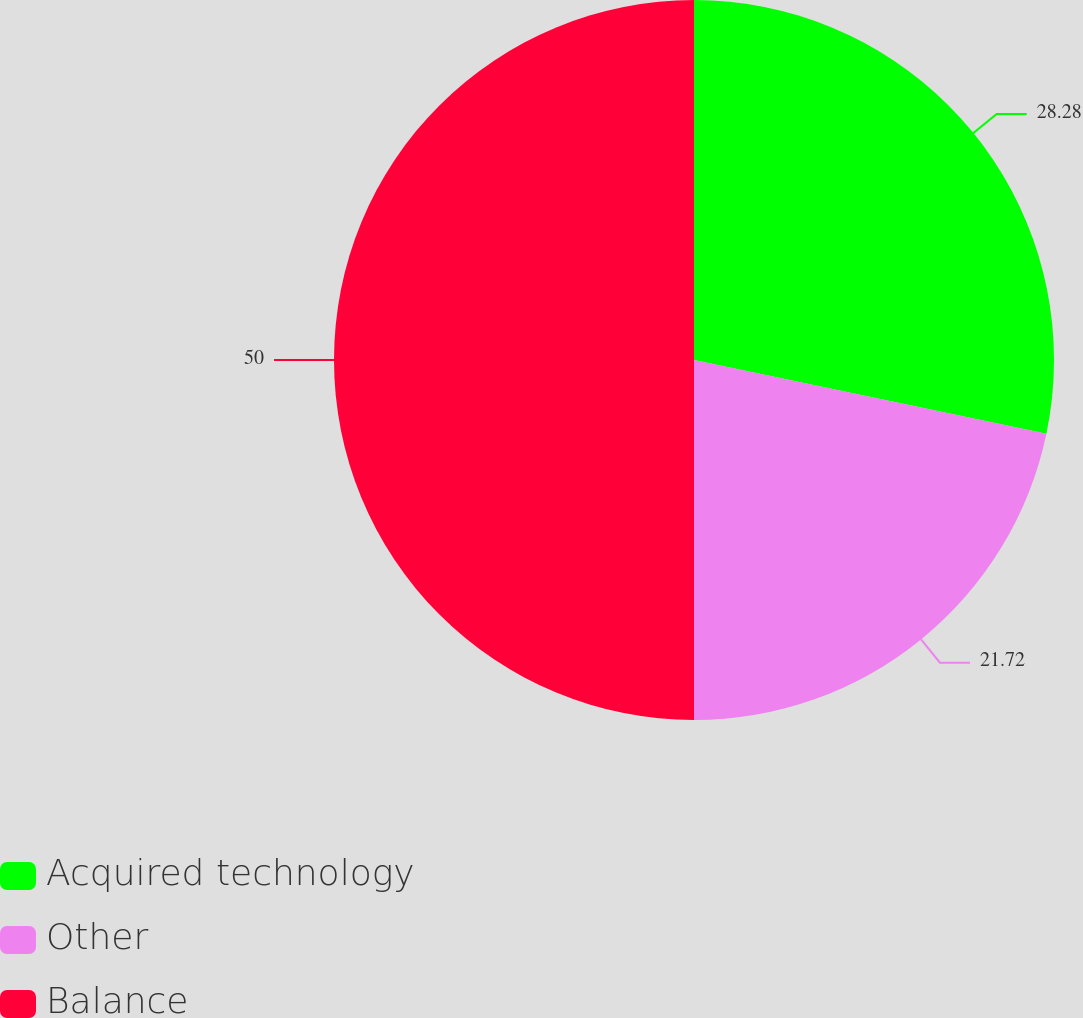<chart> <loc_0><loc_0><loc_500><loc_500><pie_chart><fcel>Acquired technology<fcel>Other<fcel>Balance<nl><fcel>28.28%<fcel>21.72%<fcel>50.0%<nl></chart> 